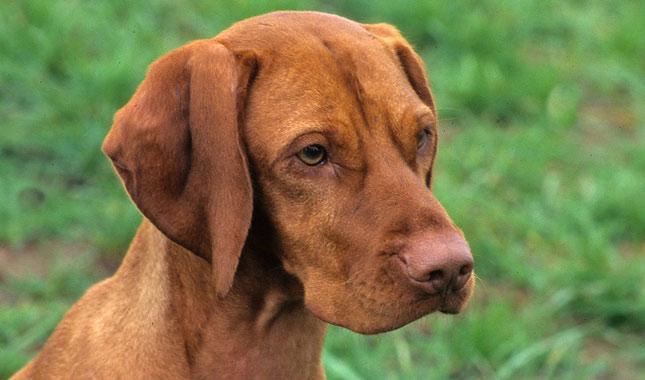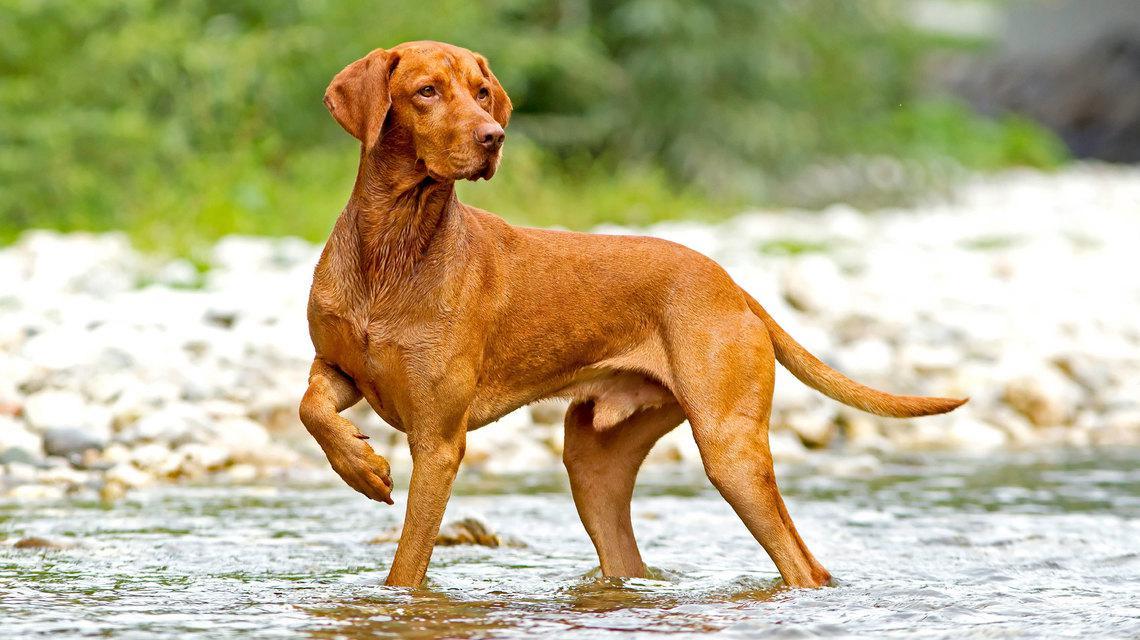The first image is the image on the left, the second image is the image on the right. Considering the images on both sides, is "At least two dogs are wearing black collars and at least half of the dogs are looking upward." valid? Answer yes or no. No. The first image is the image on the left, the second image is the image on the right. For the images displayed, is the sentence "In at least one image you can see a single brown dog looking straight forward who is wearing a coller." factually correct? Answer yes or no. No. 